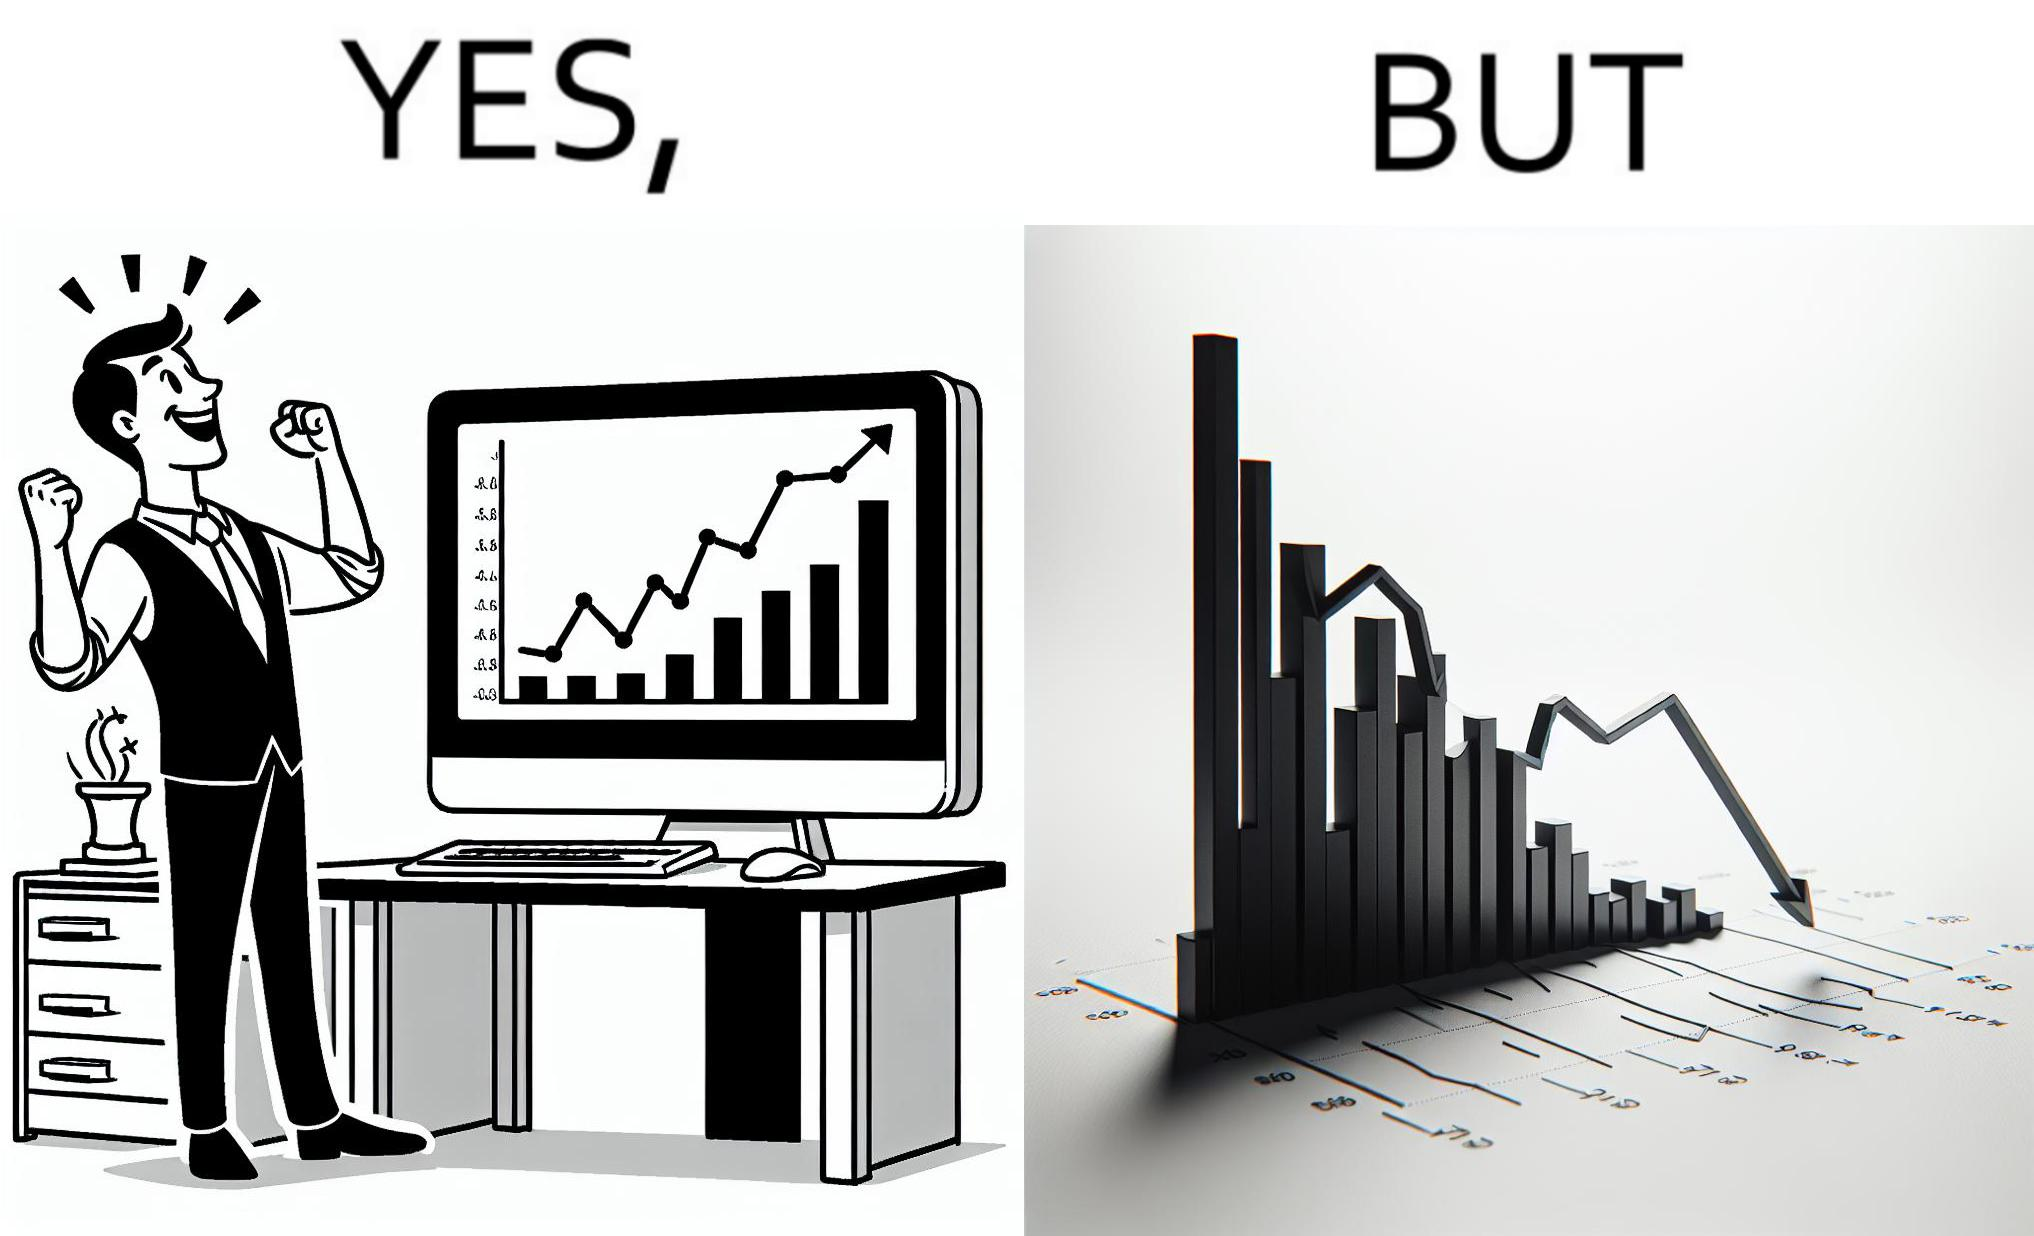What do you see in each half of this image? In the left part of the image: a person feeling proud after looking at the profit in his stocks investment In the right part of the image: a graph representing loss in some stocks 